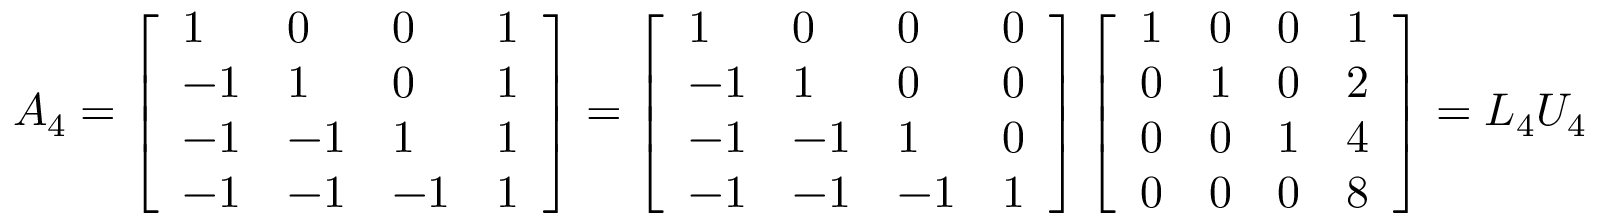<formula> <loc_0><loc_0><loc_500><loc_500>A _ { 4 } = \left [ \begin{array} { l l l l } { 1 } & { 0 } & { 0 } & { 1 } \\ { - 1 } & { 1 } & { 0 } & { 1 } \\ { - 1 } & { - 1 } & { 1 } & { 1 } \\ { - 1 } & { - 1 } & { - 1 } & { 1 } \end{array} \right ] = \left [ \begin{array} { l l l l } { 1 } & { 0 } & { 0 } & { 0 } \\ { - 1 } & { 1 } & { 0 } & { 0 } \\ { - 1 } & { - 1 } & { 1 } & { 0 } \\ { - 1 } & { - 1 } & { - 1 } & { 1 } \end{array} \right ] \left [ \begin{array} { l l l l } { 1 } & { 0 } & { 0 } & { 1 } \\ { 0 } & { 1 } & { 0 } & { 2 } \\ { 0 } & { 0 } & { 1 } & { 4 } \\ { 0 } & { 0 } & { 0 } & { 8 } \end{array} \right ] = L _ { 4 } U _ { 4 }</formula> 